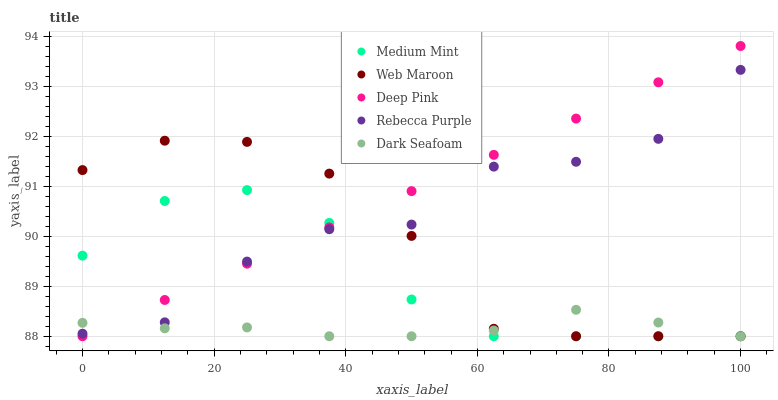Does Dark Seafoam have the minimum area under the curve?
Answer yes or no. Yes. Does Deep Pink have the maximum area under the curve?
Answer yes or no. Yes. Does Deep Pink have the minimum area under the curve?
Answer yes or no. No. Does Dark Seafoam have the maximum area under the curve?
Answer yes or no. No. Is Deep Pink the smoothest?
Answer yes or no. Yes. Is Rebecca Purple the roughest?
Answer yes or no. Yes. Is Dark Seafoam the smoothest?
Answer yes or no. No. Is Dark Seafoam the roughest?
Answer yes or no. No. Does Medium Mint have the lowest value?
Answer yes or no. Yes. Does Rebecca Purple have the lowest value?
Answer yes or no. No. Does Deep Pink have the highest value?
Answer yes or no. Yes. Does Dark Seafoam have the highest value?
Answer yes or no. No. Does Medium Mint intersect Rebecca Purple?
Answer yes or no. Yes. Is Medium Mint less than Rebecca Purple?
Answer yes or no. No. Is Medium Mint greater than Rebecca Purple?
Answer yes or no. No. 